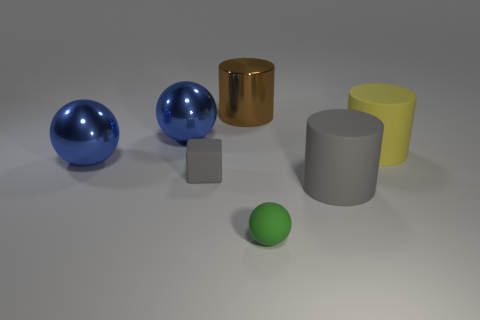Subtract all brown cylinders. How many blue balls are left? 2 Subtract all rubber cylinders. How many cylinders are left? 1 Add 3 small objects. How many objects exist? 10 Subtract all cylinders. How many objects are left? 4 Add 7 brown things. How many brown things are left? 8 Add 6 gray cylinders. How many gray cylinders exist? 7 Subtract 0 green blocks. How many objects are left? 7 Subtract all large brown metallic cylinders. Subtract all small blocks. How many objects are left? 5 